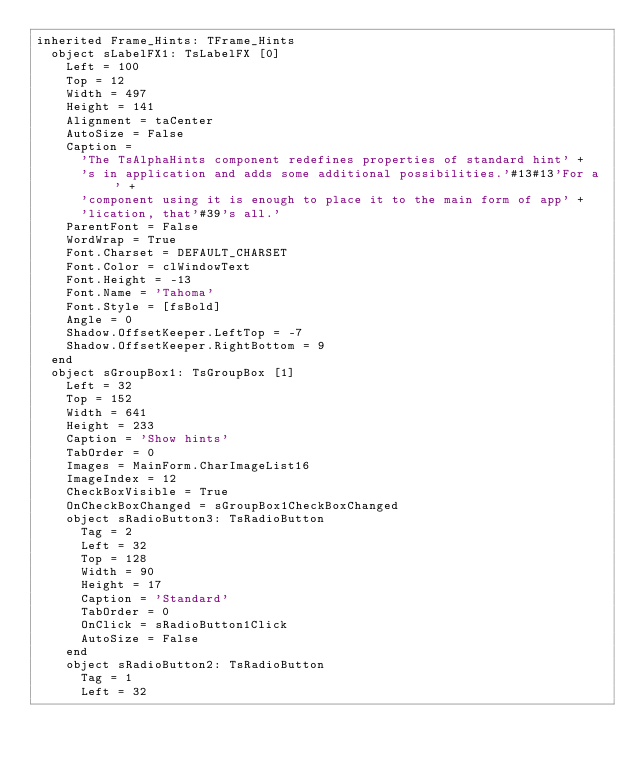<code> <loc_0><loc_0><loc_500><loc_500><_Pascal_>inherited Frame_Hints: TFrame_Hints
  object sLabelFX1: TsLabelFX [0]
    Left = 100
    Top = 12
    Width = 497
    Height = 141
    Alignment = taCenter
    AutoSize = False
    Caption = 
      'The TsAlphaHints component redefines properties of standard hint' +
      's in application and adds some additional possibilities.'#13#13'For a ' +
      'component using it is enough to place it to the main form of app' +
      'lication, that'#39's all.'
    ParentFont = False
    WordWrap = True
    Font.Charset = DEFAULT_CHARSET
    Font.Color = clWindowText
    Font.Height = -13
    Font.Name = 'Tahoma'
    Font.Style = [fsBold]
    Angle = 0
    Shadow.OffsetKeeper.LeftTop = -7
    Shadow.OffsetKeeper.RightBottom = 9
  end
  object sGroupBox1: TsGroupBox [1]
    Left = 32
    Top = 152
    Width = 641
    Height = 233
    Caption = 'Show hints'
    TabOrder = 0
    Images = MainForm.CharImageList16
    ImageIndex = 12
    CheckBoxVisible = True
    OnCheckBoxChanged = sGroupBox1CheckBoxChanged
    object sRadioButton3: TsRadioButton
      Tag = 2
      Left = 32
      Top = 128
      Width = 90
      Height = 17
      Caption = 'Standard'
      TabOrder = 0
      OnClick = sRadioButton1Click
      AutoSize = False
    end
    object sRadioButton2: TsRadioButton
      Tag = 1
      Left = 32</code> 